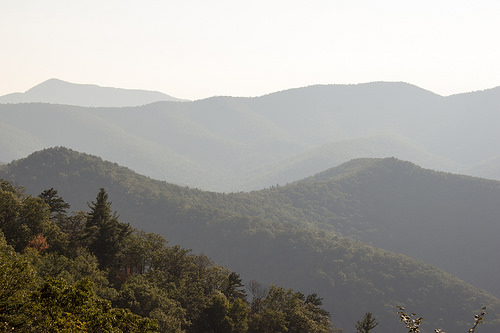<image>
Is the hills on the sky? No. The hills is not positioned on the sky. They may be near each other, but the hills is not supported by or resting on top of the sky. 